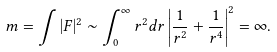<formula> <loc_0><loc_0><loc_500><loc_500>m = \int | F | ^ { 2 } \sim \int _ { 0 } ^ { \infty } r ^ { 2 } d r \left | \frac { 1 } { r ^ { 2 } } + \frac { 1 } { r ^ { 4 } } \right | ^ { 2 } = \infty .</formula> 